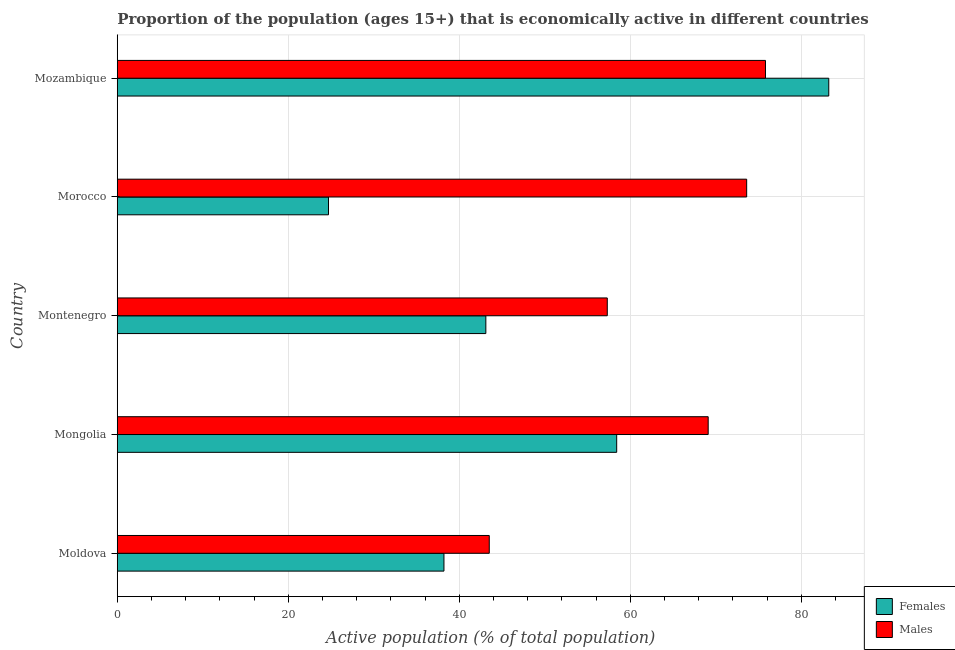How many different coloured bars are there?
Your response must be concise. 2. Are the number of bars on each tick of the Y-axis equal?
Offer a terse response. Yes. How many bars are there on the 1st tick from the top?
Your answer should be compact. 2. How many bars are there on the 1st tick from the bottom?
Keep it short and to the point. 2. What is the label of the 5th group of bars from the top?
Offer a very short reply. Moldova. In how many cases, is the number of bars for a given country not equal to the number of legend labels?
Make the answer very short. 0. What is the percentage of economically active male population in Mongolia?
Your answer should be compact. 69.1. Across all countries, what is the maximum percentage of economically active female population?
Make the answer very short. 83.2. Across all countries, what is the minimum percentage of economically active female population?
Give a very brief answer. 24.7. In which country was the percentage of economically active female population maximum?
Offer a very short reply. Mozambique. In which country was the percentage of economically active male population minimum?
Make the answer very short. Moldova. What is the total percentage of economically active female population in the graph?
Ensure brevity in your answer.  247.6. What is the difference between the percentage of economically active female population in Moldova and that in Mongolia?
Your answer should be very brief. -20.2. What is the difference between the percentage of economically active female population in Mongolia and the percentage of economically active male population in Morocco?
Provide a short and direct response. -15.2. What is the average percentage of economically active male population per country?
Offer a very short reply. 63.86. What is the difference between the percentage of economically active female population and percentage of economically active male population in Mozambique?
Ensure brevity in your answer.  7.4. In how many countries, is the percentage of economically active male population greater than 40 %?
Offer a very short reply. 5. What is the ratio of the percentage of economically active male population in Moldova to that in Mongolia?
Your response must be concise. 0.63. Is the percentage of economically active male population in Montenegro less than that in Mozambique?
Your answer should be compact. Yes. What is the difference between the highest and the second highest percentage of economically active male population?
Offer a terse response. 2.2. What is the difference between the highest and the lowest percentage of economically active male population?
Your answer should be compact. 32.3. In how many countries, is the percentage of economically active male population greater than the average percentage of economically active male population taken over all countries?
Your response must be concise. 3. What does the 1st bar from the top in Mozambique represents?
Offer a terse response. Males. What does the 1st bar from the bottom in Mongolia represents?
Provide a short and direct response. Females. How many bars are there?
Your answer should be very brief. 10. Are all the bars in the graph horizontal?
Keep it short and to the point. Yes. Does the graph contain any zero values?
Offer a terse response. No. Does the graph contain grids?
Your answer should be compact. Yes. Where does the legend appear in the graph?
Provide a short and direct response. Bottom right. How many legend labels are there?
Your response must be concise. 2. What is the title of the graph?
Your answer should be compact. Proportion of the population (ages 15+) that is economically active in different countries. What is the label or title of the X-axis?
Ensure brevity in your answer.  Active population (% of total population). What is the Active population (% of total population) of Females in Moldova?
Keep it short and to the point. 38.2. What is the Active population (% of total population) in Males in Moldova?
Your response must be concise. 43.5. What is the Active population (% of total population) of Females in Mongolia?
Ensure brevity in your answer.  58.4. What is the Active population (% of total population) in Males in Mongolia?
Your answer should be compact. 69.1. What is the Active population (% of total population) in Females in Montenegro?
Keep it short and to the point. 43.1. What is the Active population (% of total population) of Males in Montenegro?
Offer a very short reply. 57.3. What is the Active population (% of total population) of Females in Morocco?
Your answer should be very brief. 24.7. What is the Active population (% of total population) of Males in Morocco?
Offer a terse response. 73.6. What is the Active population (% of total population) in Females in Mozambique?
Ensure brevity in your answer.  83.2. What is the Active population (% of total population) of Males in Mozambique?
Your answer should be very brief. 75.8. Across all countries, what is the maximum Active population (% of total population) of Females?
Your response must be concise. 83.2. Across all countries, what is the maximum Active population (% of total population) in Males?
Make the answer very short. 75.8. Across all countries, what is the minimum Active population (% of total population) of Females?
Offer a very short reply. 24.7. Across all countries, what is the minimum Active population (% of total population) of Males?
Your answer should be very brief. 43.5. What is the total Active population (% of total population) of Females in the graph?
Provide a short and direct response. 247.6. What is the total Active population (% of total population) in Males in the graph?
Ensure brevity in your answer.  319.3. What is the difference between the Active population (% of total population) of Females in Moldova and that in Mongolia?
Provide a short and direct response. -20.2. What is the difference between the Active population (% of total population) in Males in Moldova and that in Mongolia?
Provide a succinct answer. -25.6. What is the difference between the Active population (% of total population) of Females in Moldova and that in Montenegro?
Give a very brief answer. -4.9. What is the difference between the Active population (% of total population) of Females in Moldova and that in Morocco?
Offer a very short reply. 13.5. What is the difference between the Active population (% of total population) in Males in Moldova and that in Morocco?
Your answer should be very brief. -30.1. What is the difference between the Active population (% of total population) of Females in Moldova and that in Mozambique?
Your answer should be compact. -45. What is the difference between the Active population (% of total population) in Males in Moldova and that in Mozambique?
Offer a very short reply. -32.3. What is the difference between the Active population (% of total population) of Females in Mongolia and that in Morocco?
Ensure brevity in your answer.  33.7. What is the difference between the Active population (% of total population) in Females in Mongolia and that in Mozambique?
Provide a short and direct response. -24.8. What is the difference between the Active population (% of total population) of Females in Montenegro and that in Morocco?
Ensure brevity in your answer.  18.4. What is the difference between the Active population (% of total population) of Males in Montenegro and that in Morocco?
Make the answer very short. -16.3. What is the difference between the Active population (% of total population) in Females in Montenegro and that in Mozambique?
Make the answer very short. -40.1. What is the difference between the Active population (% of total population) of Males in Montenegro and that in Mozambique?
Offer a terse response. -18.5. What is the difference between the Active population (% of total population) of Females in Morocco and that in Mozambique?
Provide a short and direct response. -58.5. What is the difference between the Active population (% of total population) in Females in Moldova and the Active population (% of total population) in Males in Mongolia?
Provide a short and direct response. -30.9. What is the difference between the Active population (% of total population) in Females in Moldova and the Active population (% of total population) in Males in Montenegro?
Offer a very short reply. -19.1. What is the difference between the Active population (% of total population) in Females in Moldova and the Active population (% of total population) in Males in Morocco?
Your answer should be compact. -35.4. What is the difference between the Active population (% of total population) of Females in Moldova and the Active population (% of total population) of Males in Mozambique?
Your answer should be compact. -37.6. What is the difference between the Active population (% of total population) of Females in Mongolia and the Active population (% of total population) of Males in Montenegro?
Your answer should be compact. 1.1. What is the difference between the Active population (% of total population) in Females in Mongolia and the Active population (% of total population) in Males in Morocco?
Your response must be concise. -15.2. What is the difference between the Active population (% of total population) of Females in Mongolia and the Active population (% of total population) of Males in Mozambique?
Provide a succinct answer. -17.4. What is the difference between the Active population (% of total population) in Females in Montenegro and the Active population (% of total population) in Males in Morocco?
Your answer should be very brief. -30.5. What is the difference between the Active population (% of total population) in Females in Montenegro and the Active population (% of total population) in Males in Mozambique?
Offer a terse response. -32.7. What is the difference between the Active population (% of total population) of Females in Morocco and the Active population (% of total population) of Males in Mozambique?
Give a very brief answer. -51.1. What is the average Active population (% of total population) of Females per country?
Your response must be concise. 49.52. What is the average Active population (% of total population) of Males per country?
Provide a succinct answer. 63.86. What is the difference between the Active population (% of total population) in Females and Active population (% of total population) in Males in Moldova?
Keep it short and to the point. -5.3. What is the difference between the Active population (% of total population) in Females and Active population (% of total population) in Males in Morocco?
Keep it short and to the point. -48.9. What is the difference between the Active population (% of total population) in Females and Active population (% of total population) in Males in Mozambique?
Keep it short and to the point. 7.4. What is the ratio of the Active population (% of total population) of Females in Moldova to that in Mongolia?
Your response must be concise. 0.65. What is the ratio of the Active population (% of total population) in Males in Moldova to that in Mongolia?
Your answer should be compact. 0.63. What is the ratio of the Active population (% of total population) in Females in Moldova to that in Montenegro?
Your response must be concise. 0.89. What is the ratio of the Active population (% of total population) in Males in Moldova to that in Montenegro?
Your answer should be very brief. 0.76. What is the ratio of the Active population (% of total population) of Females in Moldova to that in Morocco?
Make the answer very short. 1.55. What is the ratio of the Active population (% of total population) of Males in Moldova to that in Morocco?
Give a very brief answer. 0.59. What is the ratio of the Active population (% of total population) of Females in Moldova to that in Mozambique?
Ensure brevity in your answer.  0.46. What is the ratio of the Active population (% of total population) of Males in Moldova to that in Mozambique?
Your answer should be very brief. 0.57. What is the ratio of the Active population (% of total population) in Females in Mongolia to that in Montenegro?
Offer a terse response. 1.35. What is the ratio of the Active population (% of total population) of Males in Mongolia to that in Montenegro?
Keep it short and to the point. 1.21. What is the ratio of the Active population (% of total population) in Females in Mongolia to that in Morocco?
Offer a very short reply. 2.36. What is the ratio of the Active population (% of total population) of Males in Mongolia to that in Morocco?
Keep it short and to the point. 0.94. What is the ratio of the Active population (% of total population) in Females in Mongolia to that in Mozambique?
Keep it short and to the point. 0.7. What is the ratio of the Active population (% of total population) in Males in Mongolia to that in Mozambique?
Give a very brief answer. 0.91. What is the ratio of the Active population (% of total population) of Females in Montenegro to that in Morocco?
Your answer should be very brief. 1.74. What is the ratio of the Active population (% of total population) in Males in Montenegro to that in Morocco?
Keep it short and to the point. 0.78. What is the ratio of the Active population (% of total population) of Females in Montenegro to that in Mozambique?
Offer a very short reply. 0.52. What is the ratio of the Active population (% of total population) in Males in Montenegro to that in Mozambique?
Provide a succinct answer. 0.76. What is the ratio of the Active population (% of total population) in Females in Morocco to that in Mozambique?
Your response must be concise. 0.3. What is the difference between the highest and the second highest Active population (% of total population) of Females?
Make the answer very short. 24.8. What is the difference between the highest and the second highest Active population (% of total population) in Males?
Provide a short and direct response. 2.2. What is the difference between the highest and the lowest Active population (% of total population) in Females?
Your response must be concise. 58.5. What is the difference between the highest and the lowest Active population (% of total population) in Males?
Offer a very short reply. 32.3. 